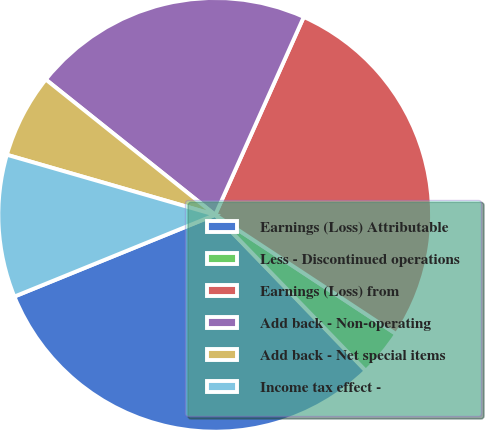Convert chart. <chart><loc_0><loc_0><loc_500><loc_500><pie_chart><fcel>Earnings (Loss) Attributable<fcel>Less - Discontinued operations<fcel>Earnings (Loss) from<fcel>Add back - Non-operating<fcel>Add back - Net special items<fcel>Income tax effect -<nl><fcel>31.07%<fcel>3.51%<fcel>27.57%<fcel>20.97%<fcel>6.26%<fcel>10.62%<nl></chart> 